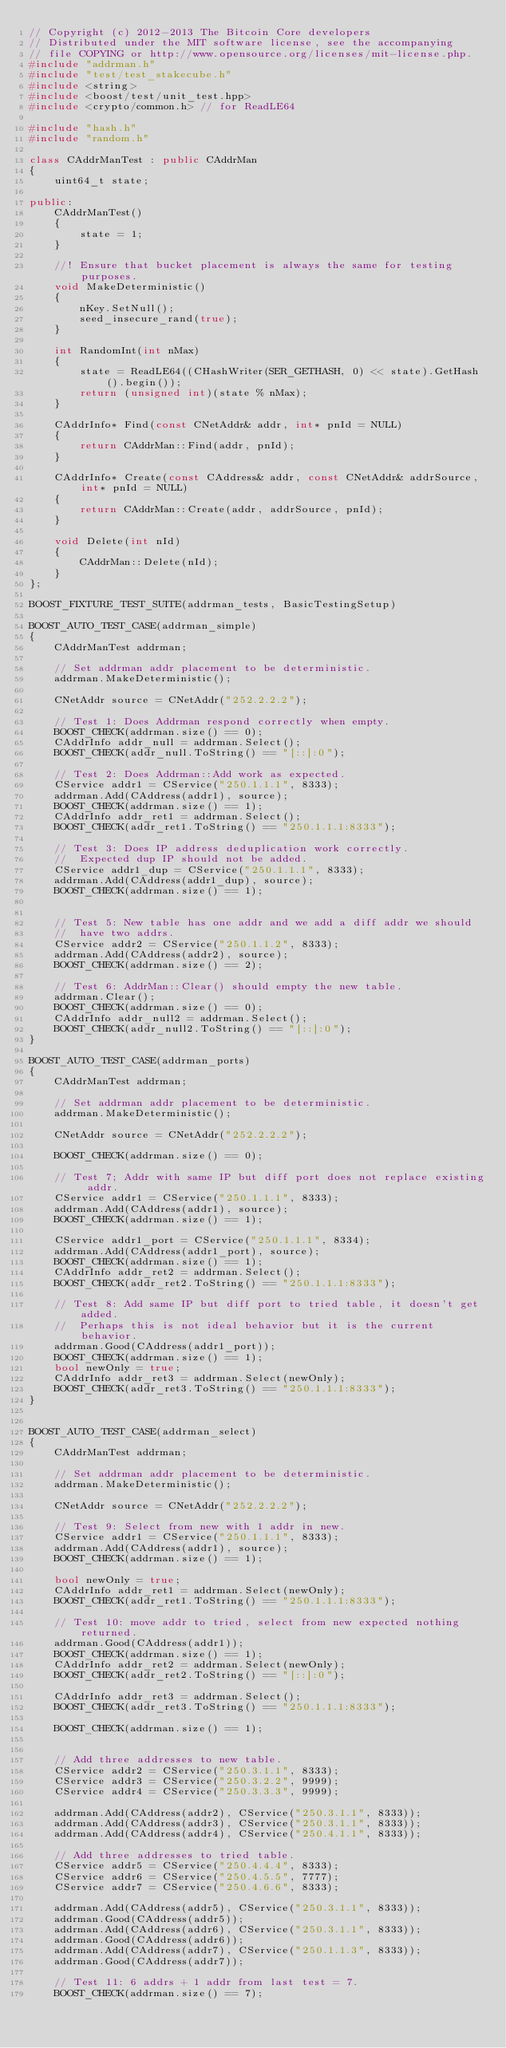<code> <loc_0><loc_0><loc_500><loc_500><_C++_>// Copyright (c) 2012-2013 The Bitcoin Core developers
// Distributed under the MIT software license, see the accompanying
// file COPYING or http://www.opensource.org/licenses/mit-license.php.
#include "addrman.h"
#include "test/test_stakecube.h"
#include <string>
#include <boost/test/unit_test.hpp>
#include <crypto/common.h> // for ReadLE64

#include "hash.h"
#include "random.h"

class CAddrManTest : public CAddrMan
{
    uint64_t state;

public:
    CAddrManTest()
    {
        state = 1;
    }

    //! Ensure that bucket placement is always the same for testing purposes.
    void MakeDeterministic()
    {
        nKey.SetNull();
        seed_insecure_rand(true);
    }

    int RandomInt(int nMax)
    {
        state = ReadLE64((CHashWriter(SER_GETHASH, 0) << state).GetHash().begin());
        return (unsigned int)(state % nMax);
    }

    CAddrInfo* Find(const CNetAddr& addr, int* pnId = NULL)
    {
        return CAddrMan::Find(addr, pnId);
    }

    CAddrInfo* Create(const CAddress& addr, const CNetAddr& addrSource, int* pnId = NULL)
    {
        return CAddrMan::Create(addr, addrSource, pnId);
    }

    void Delete(int nId)
    {
        CAddrMan::Delete(nId);
    }
};

BOOST_FIXTURE_TEST_SUITE(addrman_tests, BasicTestingSetup)

BOOST_AUTO_TEST_CASE(addrman_simple)
{
    CAddrManTest addrman;

    // Set addrman addr placement to be deterministic.
    addrman.MakeDeterministic();

    CNetAddr source = CNetAddr("252.2.2.2");

    // Test 1: Does Addrman respond correctly when empty.
    BOOST_CHECK(addrman.size() == 0);
    CAddrInfo addr_null = addrman.Select();
    BOOST_CHECK(addr_null.ToString() == "[::]:0");

    // Test 2: Does Addrman::Add work as expected.
    CService addr1 = CService("250.1.1.1", 8333);
    addrman.Add(CAddress(addr1), source);
    BOOST_CHECK(addrman.size() == 1);
    CAddrInfo addr_ret1 = addrman.Select();
    BOOST_CHECK(addr_ret1.ToString() == "250.1.1.1:8333");

    // Test 3: Does IP address deduplication work correctly.
    //  Expected dup IP should not be added.
    CService addr1_dup = CService("250.1.1.1", 8333);
    addrman.Add(CAddress(addr1_dup), source);
    BOOST_CHECK(addrman.size() == 1);


    // Test 5: New table has one addr and we add a diff addr we should
    //  have two addrs.
    CService addr2 = CService("250.1.1.2", 8333);
    addrman.Add(CAddress(addr2), source);
    BOOST_CHECK(addrman.size() == 2);

    // Test 6: AddrMan::Clear() should empty the new table.
    addrman.Clear();
    BOOST_CHECK(addrman.size() == 0);
    CAddrInfo addr_null2 = addrman.Select();
    BOOST_CHECK(addr_null2.ToString() == "[::]:0");
}

BOOST_AUTO_TEST_CASE(addrman_ports)
{
    CAddrManTest addrman;

    // Set addrman addr placement to be deterministic.
    addrman.MakeDeterministic();

    CNetAddr source = CNetAddr("252.2.2.2");

    BOOST_CHECK(addrman.size() == 0);

    // Test 7; Addr with same IP but diff port does not replace existing addr.
    CService addr1 = CService("250.1.1.1", 8333);
    addrman.Add(CAddress(addr1), source);
    BOOST_CHECK(addrman.size() == 1);

    CService addr1_port = CService("250.1.1.1", 8334);
    addrman.Add(CAddress(addr1_port), source);
    BOOST_CHECK(addrman.size() == 1);
    CAddrInfo addr_ret2 = addrman.Select();
    BOOST_CHECK(addr_ret2.ToString() == "250.1.1.1:8333");

    // Test 8: Add same IP but diff port to tried table, it doesn't get added.
    //  Perhaps this is not ideal behavior but it is the current behavior.
    addrman.Good(CAddress(addr1_port));
    BOOST_CHECK(addrman.size() == 1);
    bool newOnly = true;
    CAddrInfo addr_ret3 = addrman.Select(newOnly);
    BOOST_CHECK(addr_ret3.ToString() == "250.1.1.1:8333");
}


BOOST_AUTO_TEST_CASE(addrman_select)
{
    CAddrManTest addrman;

    // Set addrman addr placement to be deterministic.
    addrman.MakeDeterministic();

    CNetAddr source = CNetAddr("252.2.2.2");

    // Test 9: Select from new with 1 addr in new.
    CService addr1 = CService("250.1.1.1", 8333);
    addrman.Add(CAddress(addr1), source);
    BOOST_CHECK(addrman.size() == 1);

    bool newOnly = true;
    CAddrInfo addr_ret1 = addrman.Select(newOnly);
    BOOST_CHECK(addr_ret1.ToString() == "250.1.1.1:8333");

    // Test 10: move addr to tried, select from new expected nothing returned.
    addrman.Good(CAddress(addr1));
    BOOST_CHECK(addrman.size() == 1);
    CAddrInfo addr_ret2 = addrman.Select(newOnly);
    BOOST_CHECK(addr_ret2.ToString() == "[::]:0");

    CAddrInfo addr_ret3 = addrman.Select();
    BOOST_CHECK(addr_ret3.ToString() == "250.1.1.1:8333");

    BOOST_CHECK(addrman.size() == 1);


    // Add three addresses to new table.
    CService addr2 = CService("250.3.1.1", 8333);
    CService addr3 = CService("250.3.2.2", 9999);
    CService addr4 = CService("250.3.3.3", 9999);

    addrman.Add(CAddress(addr2), CService("250.3.1.1", 8333));
    addrman.Add(CAddress(addr3), CService("250.3.1.1", 8333));
    addrman.Add(CAddress(addr4), CService("250.4.1.1", 8333));

    // Add three addresses to tried table.
    CService addr5 = CService("250.4.4.4", 8333);
    CService addr6 = CService("250.4.5.5", 7777);
    CService addr7 = CService("250.4.6.6", 8333);

    addrman.Add(CAddress(addr5), CService("250.3.1.1", 8333));
    addrman.Good(CAddress(addr5));
    addrman.Add(CAddress(addr6), CService("250.3.1.1", 8333));
    addrman.Good(CAddress(addr6));
    addrman.Add(CAddress(addr7), CService("250.1.1.3", 8333));
    addrman.Good(CAddress(addr7));

    // Test 11: 6 addrs + 1 addr from last test = 7.
    BOOST_CHECK(addrman.size() == 7);
</code> 